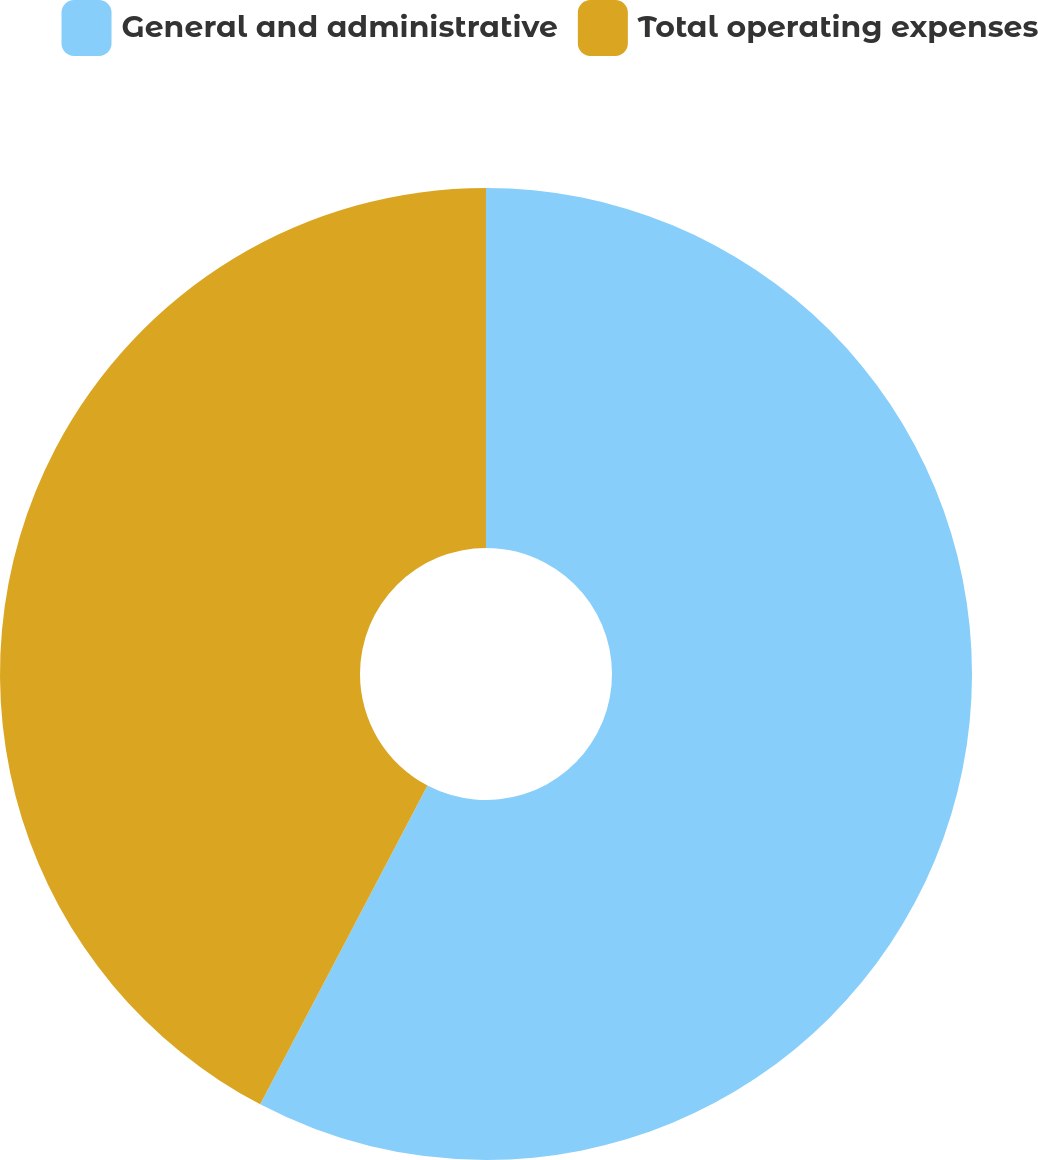Convert chart to OTSL. <chart><loc_0><loc_0><loc_500><loc_500><pie_chart><fcel>General and administrative<fcel>Total operating expenses<nl><fcel>57.69%<fcel>42.31%<nl></chart> 